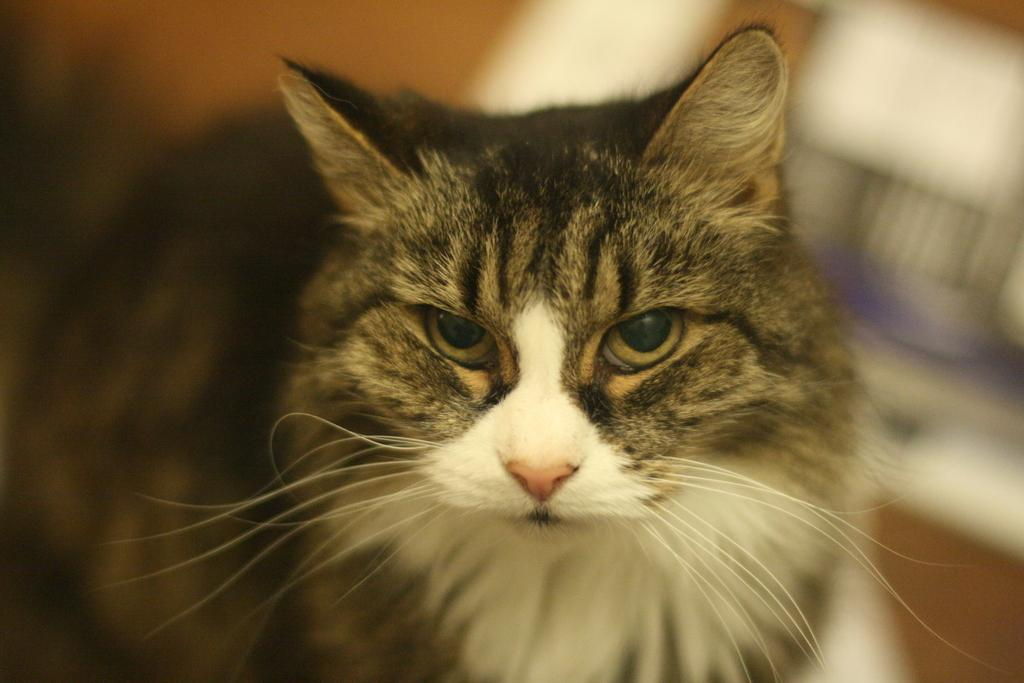What type of animal is in the image? There is a cat in the image. Can you describe the appearance of the cat? The cat is black and white in color. What scientific discovery is the cat making in the image? There is no scientific discovery being made by the cat in the image, as it is simply a black and white cat. 